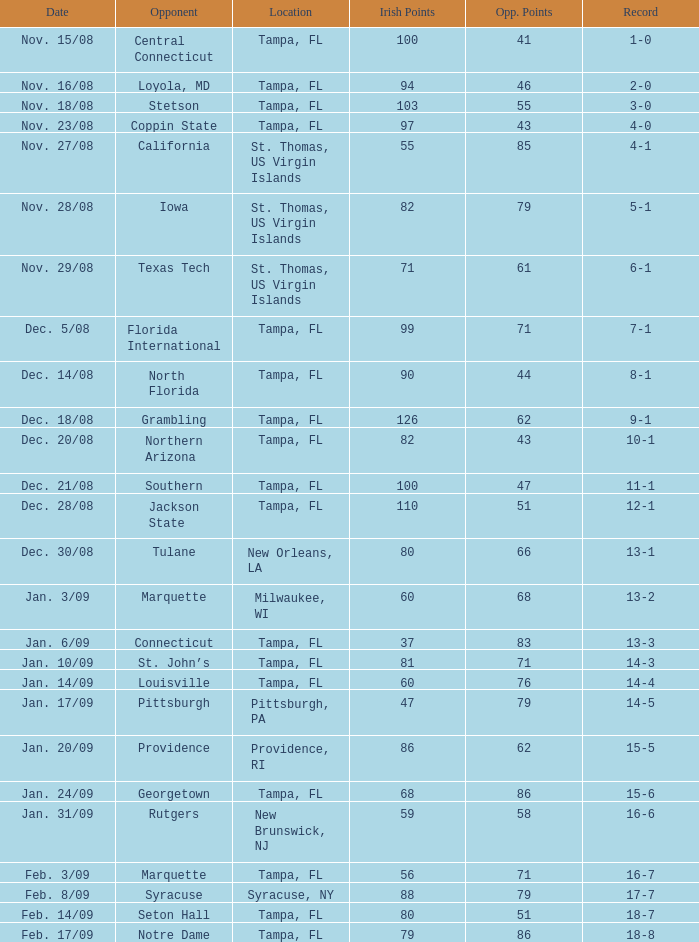What is the record where the opponent is central connecticut? 1-0. 